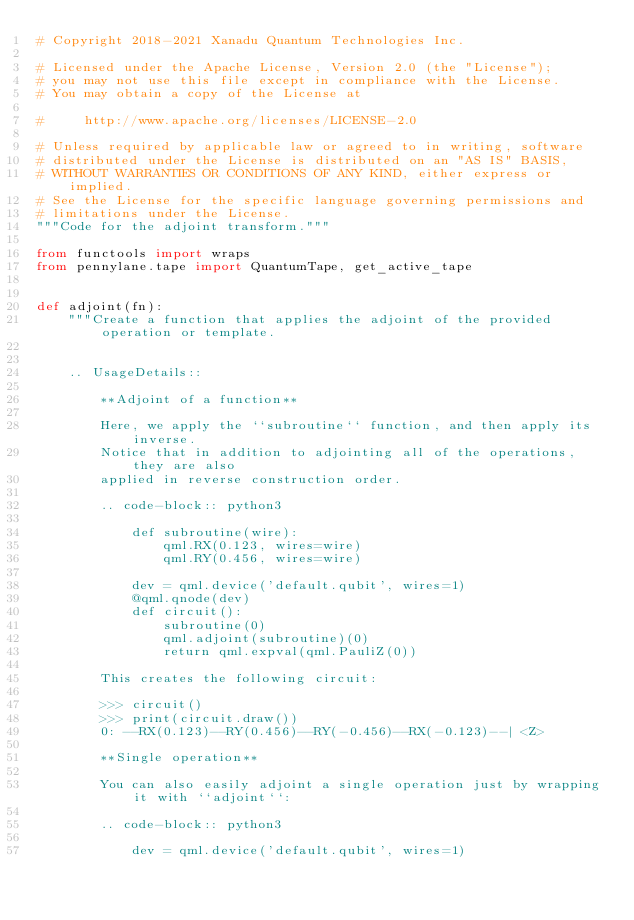<code> <loc_0><loc_0><loc_500><loc_500><_Python_># Copyright 2018-2021 Xanadu Quantum Technologies Inc.

# Licensed under the Apache License, Version 2.0 (the "License");
# you may not use this file except in compliance with the License.
# You may obtain a copy of the License at

#     http://www.apache.org/licenses/LICENSE-2.0

# Unless required by applicable law or agreed to in writing, software
# distributed under the License is distributed on an "AS IS" BASIS,
# WITHOUT WARRANTIES OR CONDITIONS OF ANY KIND, either express or implied.
# See the License for the specific language governing permissions and
# limitations under the License.
"""Code for the adjoint transform."""

from functools import wraps
from pennylane.tape import QuantumTape, get_active_tape


def adjoint(fn):
    """Create a function that applies the adjoint of the provided operation or template.


    .. UsageDetails::

        **Adjoint of a function**

        Here, we apply the ``subroutine`` function, and then apply its inverse.
        Notice that in addition to adjointing all of the operations, they are also
        applied in reverse construction order.

        .. code-block:: python3

            def subroutine(wire):
                qml.RX(0.123, wires=wire)
                qml.RY(0.456, wires=wire)

            dev = qml.device('default.qubit', wires=1)
            @qml.qnode(dev)
            def circuit():
                subroutine(0)
                qml.adjoint(subroutine)(0)
                return qml.expval(qml.PauliZ(0))

        This creates the following circuit:

        >>> circuit()
        >>> print(circuit.draw())
        0: --RX(0.123)--RY(0.456)--RY(-0.456)--RX(-0.123)--| <Z>

        **Single operation**

        You can also easily adjoint a single operation just by wrapping it with ``adjoint``:

        .. code-block:: python3

            dev = qml.device('default.qubit', wires=1)</code> 